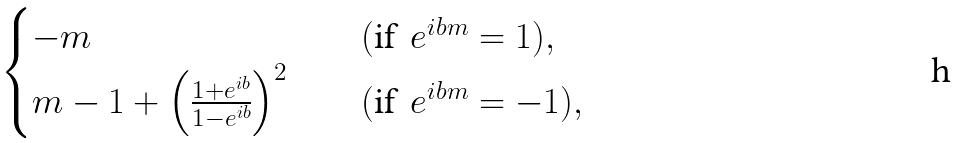Convert formula to latex. <formula><loc_0><loc_0><loc_500><loc_500>\begin{cases} - m & \quad ( \text {if} \, \ e ^ { i b m } = 1 ) , \\ m - 1 + \left ( \frac { 1 + e ^ { i b } } { 1 - e ^ { i b } } \right ) ^ { 2 } & \quad ( \text {if} \, \ e ^ { i b m } = - 1 ) , \end{cases}</formula> 